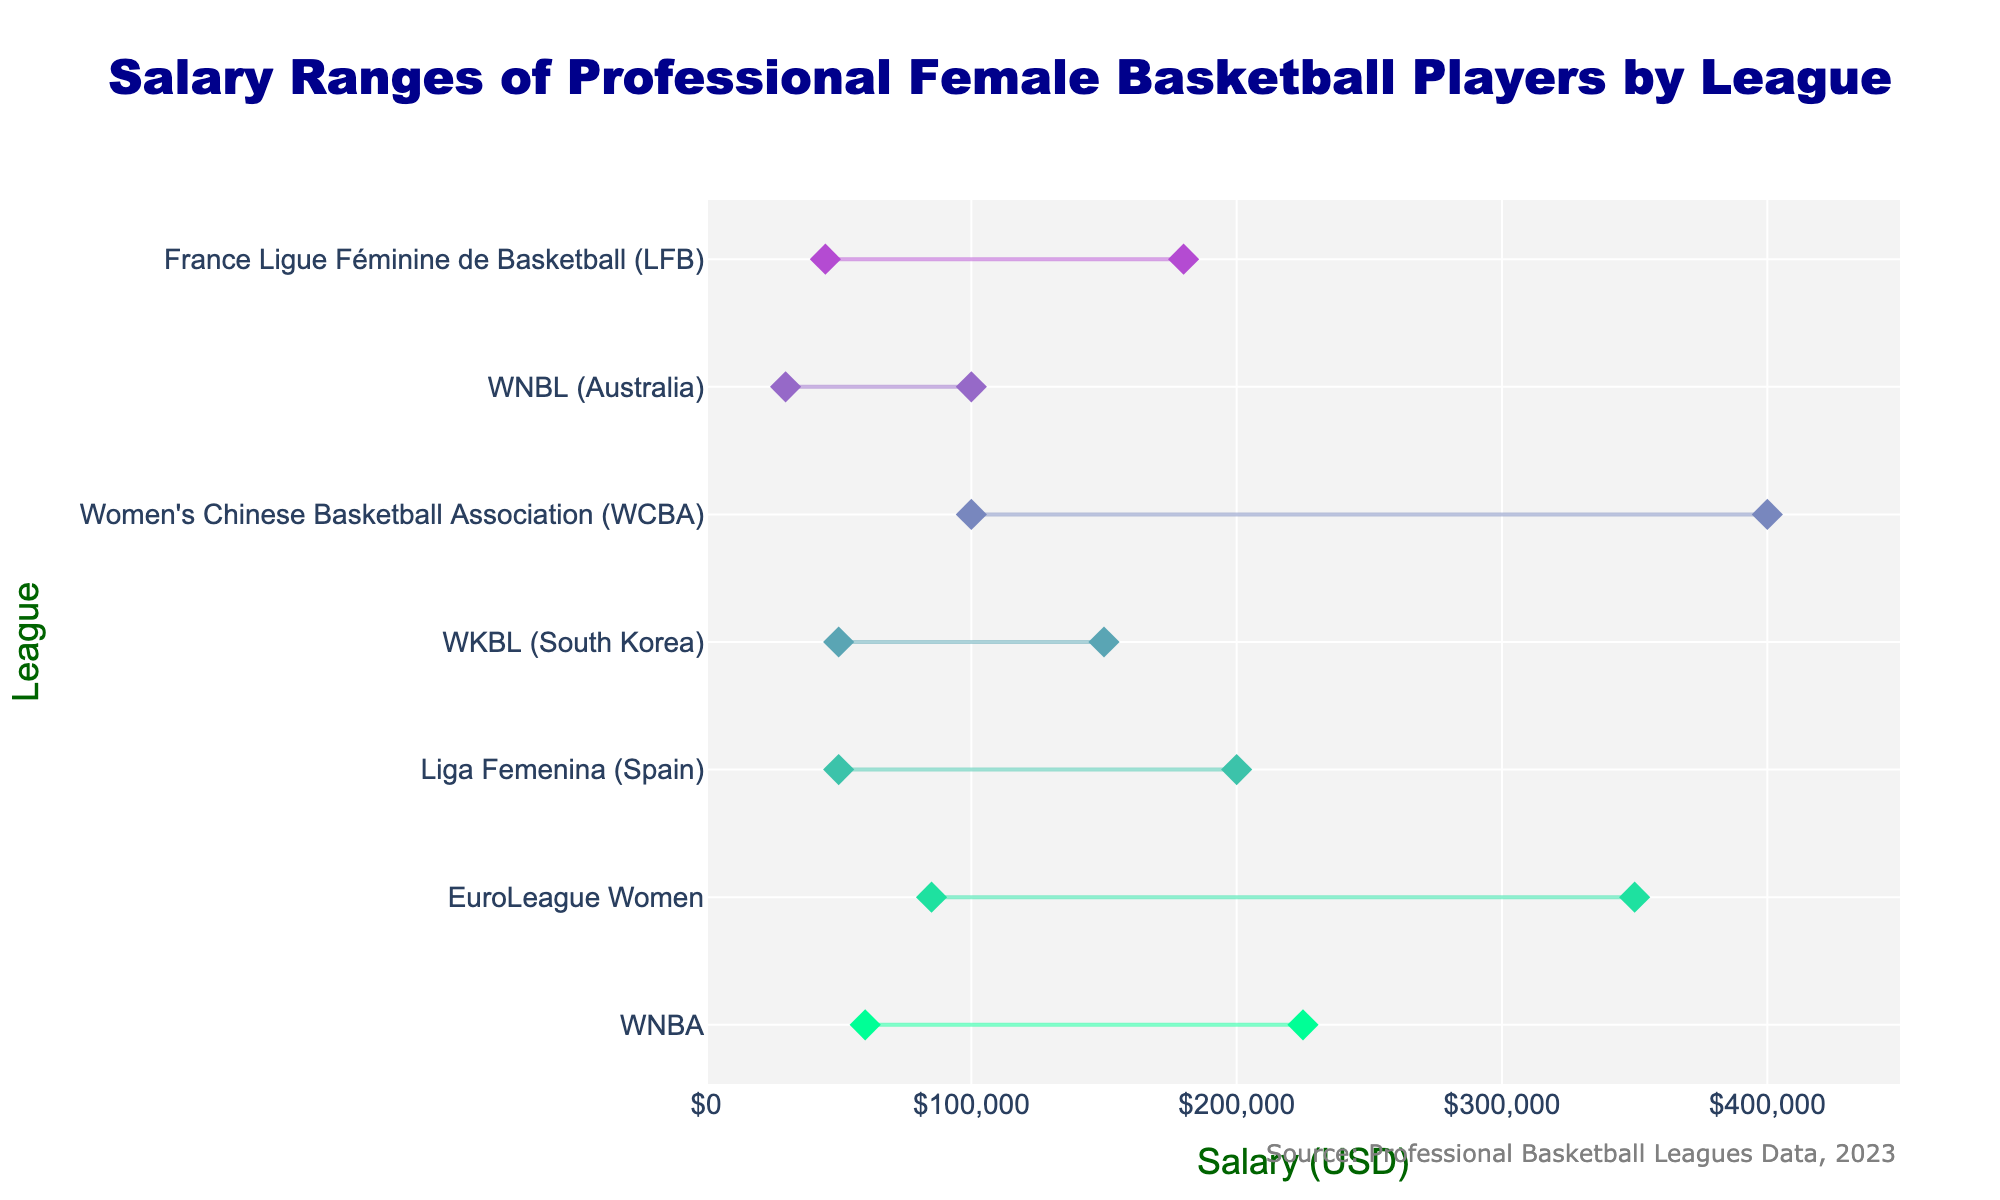What is the title of the figure? The title of the figure is located at the top center. It is: "Salary Ranges of Professional Female Basketball Players by League".
Answer: Salary Ranges of Professional Female Basketball Players by League What is the maximum salary shown for players in the WNBA? To find the maximum salary, look at the end of the line corresponding to the WNBA. It shows $225,000.
Answer: $225,000 Which league offers the highest maximum salary for players? Identify the league with the rightmost position on the x-axis. The WCBA (Women's Chinese Basketball Association) shows the highest maximum salary of $400,000.
Answer: WCBA What is the range of salaries in the WNBL (Australia)? Determine the difference between the maximum and minimum salaries for the WNBL by looking at the ends of the horizontal line. The range is $100,000 - $30,000 = $70,000.
Answer: $70,000 Among the leagues depicted, which one has the smallest salary range? To find the smallest range, look for the shortest line horizontally. The WNBL (Australia) has the smallest range with a difference of $70,000.
Answer: WNBL How many leagues have a minimum salary of at least $50,000? Count the number of leagues where the left endpoint of the line starts at or above $50,000. The leagues are EuroLeague Women, Liga Femenina, WKBL, WCBA, and France Ligue Féminine de Basketball (LFB).
Answer: 5 What is the difference between the maximum salary in the WCBA and the minimum salary in the WNBL? Subtract the minimum salary in WNBL from the maximum salary in WCBA: $400,000 (WCBA) - $30,000 (WNBL) = $370,000.
Answer: $370,000 Which leagues have a minimum salary less than $60,000? Look at the left endpoints of the lines. The leagues with a minimum salary less than $60,000 are Liga Femenina (Spain), WKBL (South Korea), WNBL (Australia), and France Ligue Féminine de Basketball (LFB).
Answer: Liga Femenina, WKBL, WNBL, LFB Compare the salary ranges between EuroLeague Women and WCBA. Which one is larger? Calculate the salary range by subtracting the minimum salary from the maximum salary for each league. EuroLeague Women: $350,000 - $85,000 = $265,000; WCBA: $400,000 - $100,000 = $300,000. WCBA has a larger range with $300,000.
Answer: WCBA What is the average salary range across all leagues? Calculate the salary range for each league, sum them up, and divide by the total number of leagues. 
WNBA: $225,000 - $60,000 = $165,000
EuroLeague Women: $350,000 - $85,000 = $265,000
Liga Femenina: $200,000 - $50,000 = $150,000
WKBL: $150,000 - $50,000 = $100,000
WCBA: $400,000 - $100,000 = $300,000
WNBL: $100,000 - $30,000 = $70,000
LFB: $180,000 - $45,000 = $135,000
Total range = $165,000 + $265,000 + $150,000 + $100,000 + $300,000 + $70,000 + $135,000 = $1,185,000
Average range = $1,185,000 / 7 = $169,285.71.
Answer: $169,285.71 